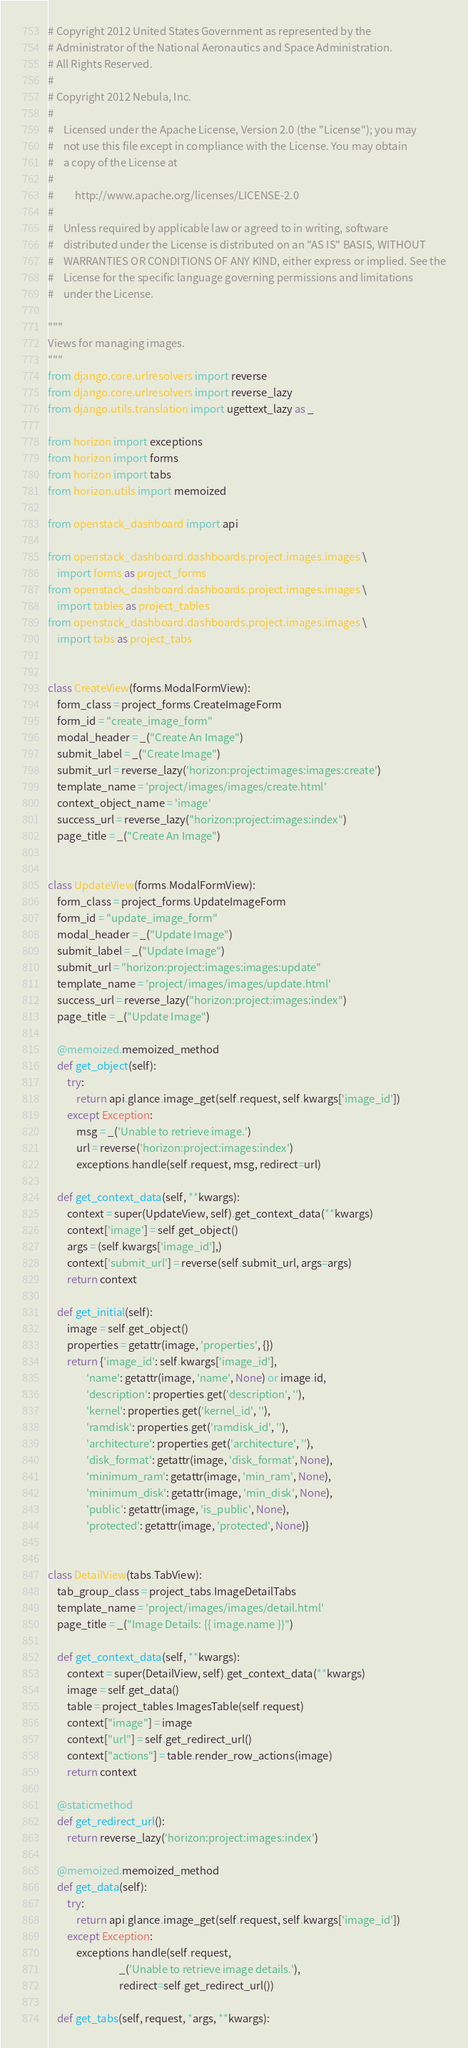<code> <loc_0><loc_0><loc_500><loc_500><_Python_># Copyright 2012 United States Government as represented by the
# Administrator of the National Aeronautics and Space Administration.
# All Rights Reserved.
#
# Copyright 2012 Nebula, Inc.
#
#    Licensed under the Apache License, Version 2.0 (the "License"); you may
#    not use this file except in compliance with the License. You may obtain
#    a copy of the License at
#
#         http://www.apache.org/licenses/LICENSE-2.0
#
#    Unless required by applicable law or agreed to in writing, software
#    distributed under the License is distributed on an "AS IS" BASIS, WITHOUT
#    WARRANTIES OR CONDITIONS OF ANY KIND, either express or implied. See the
#    License for the specific language governing permissions and limitations
#    under the License.

"""
Views for managing images.
"""
from django.core.urlresolvers import reverse
from django.core.urlresolvers import reverse_lazy
from django.utils.translation import ugettext_lazy as _

from horizon import exceptions
from horizon import forms
from horizon import tabs
from horizon.utils import memoized

from openstack_dashboard import api

from openstack_dashboard.dashboards.project.images.images \
    import forms as project_forms
from openstack_dashboard.dashboards.project.images.images \
    import tables as project_tables
from openstack_dashboard.dashboards.project.images.images \
    import tabs as project_tabs


class CreateView(forms.ModalFormView):
    form_class = project_forms.CreateImageForm
    form_id = "create_image_form"
    modal_header = _("Create An Image")
    submit_label = _("Create Image")
    submit_url = reverse_lazy('horizon:project:images:images:create')
    template_name = 'project/images/images/create.html'
    context_object_name = 'image'
    success_url = reverse_lazy("horizon:project:images:index")
    page_title = _("Create An Image")


class UpdateView(forms.ModalFormView):
    form_class = project_forms.UpdateImageForm
    form_id = "update_image_form"
    modal_header = _("Update Image")
    submit_label = _("Update Image")
    submit_url = "horizon:project:images:images:update"
    template_name = 'project/images/images/update.html'
    success_url = reverse_lazy("horizon:project:images:index")
    page_title = _("Update Image")

    @memoized.memoized_method
    def get_object(self):
        try:
            return api.glance.image_get(self.request, self.kwargs['image_id'])
        except Exception:
            msg = _('Unable to retrieve image.')
            url = reverse('horizon:project:images:index')
            exceptions.handle(self.request, msg, redirect=url)

    def get_context_data(self, **kwargs):
        context = super(UpdateView, self).get_context_data(**kwargs)
        context['image'] = self.get_object()
        args = (self.kwargs['image_id'],)
        context['submit_url'] = reverse(self.submit_url, args=args)
        return context

    def get_initial(self):
        image = self.get_object()
        properties = getattr(image, 'properties', {})
        return {'image_id': self.kwargs['image_id'],
                'name': getattr(image, 'name', None) or image.id,
                'description': properties.get('description', ''),
                'kernel': properties.get('kernel_id', ''),
                'ramdisk': properties.get('ramdisk_id', ''),
                'architecture': properties.get('architecture', ''),
                'disk_format': getattr(image, 'disk_format', None),
                'minimum_ram': getattr(image, 'min_ram', None),
                'minimum_disk': getattr(image, 'min_disk', None),
                'public': getattr(image, 'is_public', None),
                'protected': getattr(image, 'protected', None)}


class DetailView(tabs.TabView):
    tab_group_class = project_tabs.ImageDetailTabs
    template_name = 'project/images/images/detail.html'
    page_title = _("Image Details: {{ image.name }}")

    def get_context_data(self, **kwargs):
        context = super(DetailView, self).get_context_data(**kwargs)
        image = self.get_data()
        table = project_tables.ImagesTable(self.request)
        context["image"] = image
        context["url"] = self.get_redirect_url()
        context["actions"] = table.render_row_actions(image)
        return context

    @staticmethod
    def get_redirect_url():
        return reverse_lazy('horizon:project:images:index')

    @memoized.memoized_method
    def get_data(self):
        try:
            return api.glance.image_get(self.request, self.kwargs['image_id'])
        except Exception:
            exceptions.handle(self.request,
                              _('Unable to retrieve image details.'),
                              redirect=self.get_redirect_url())

    def get_tabs(self, request, *args, **kwargs):</code> 